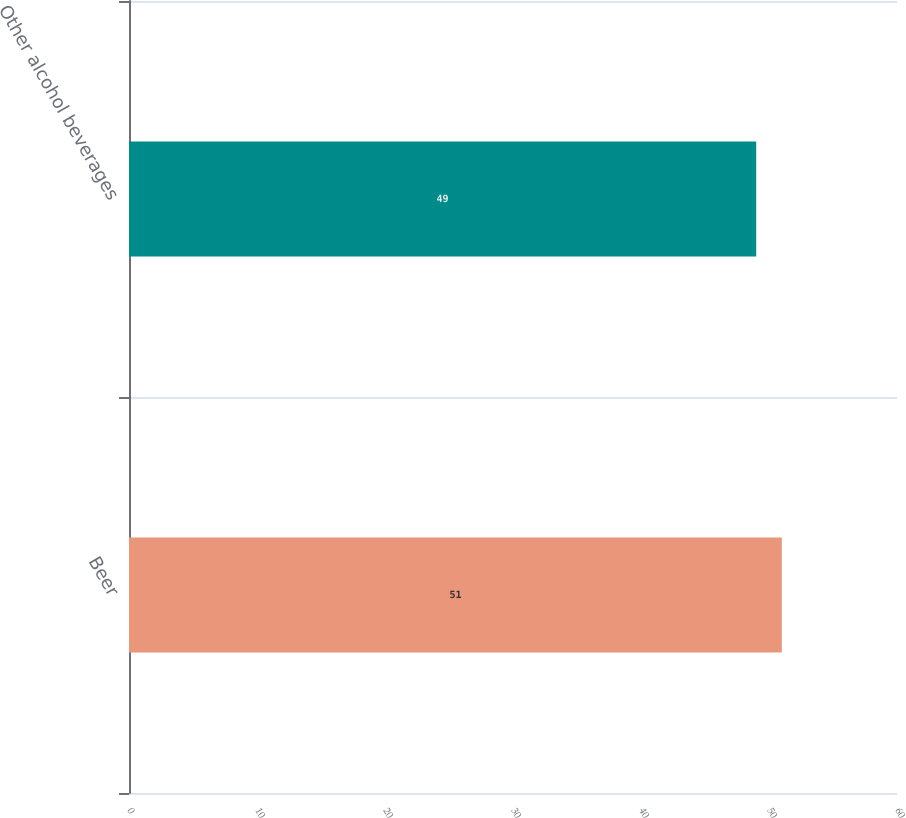<chart> <loc_0><loc_0><loc_500><loc_500><bar_chart><fcel>Beer<fcel>Other alcohol beverages<nl><fcel>51<fcel>49<nl></chart> 